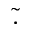Convert formula to latex. <formula><loc_0><loc_0><loc_500><loc_500>\tilde { . }</formula> 